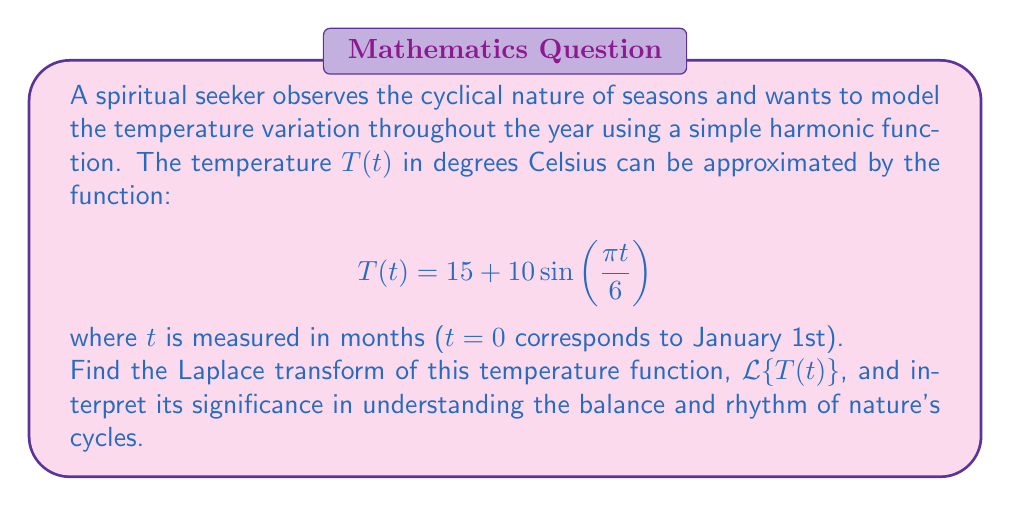Show me your answer to this math problem. To solve this problem, we'll follow these steps:

1) Recall the Laplace transform of a sine function:
   $$\mathcal{L}\{\sin(at)\} = \frac{a}{s^2 + a^2}$$

2) In our case, $a = \frac{\pi}{6}$, so we need to find:
   $$\mathcal{L}\{10\sin(\frac{\pi t}{6})\}$$

3) Using the linearity property of Laplace transforms and the transform of a constant:
   $$\mathcal{L}\{15\} = \frac{15}{s}$$

4) Combining these results:
   $$\mathcal{L}\{T(t)\} = \mathcal{L}\{15 + 10\sin(\frac{\pi t}{6})\}$$
   $$= \mathcal{L}\{15\} + \mathcal{L}\{10\sin(\frac{\pi t}{6})\}$$
   $$= \frac{15}{s} + 10 \cdot \frac{\frac{\pi}{6}}{s^2 + (\frac{\pi}{6})^2}$$

5) Simplifying:
   $$\mathcal{L}\{T(t)\} = \frac{15}{s} + \frac{5\pi}{3s^2 + (\frac{\pi}{6})^2}$$

Interpretation: The Laplace transform provides insights into the balance and rhythm of nature's cycles:

- The term $\frac{15}{s}$ represents the average temperature throughout the year.
- The term $\frac{5\pi}{3s^2 + (\frac{\pi}{6})^2}$ captures the seasonal variations.
- The denominator $3s^2 + (\frac{\pi}{6})^2$ reflects the yearly cycle frequency.

This transform allows us to analyze the temperature function in the frequency domain, highlighting the harmonic nature of seasonal changes and the underlying balance in nature's rhythms.
Answer: $$\mathcal{L}\{T(t)\} = \frac{15}{s} + \frac{5\pi}{3s^2 + (\frac{\pi}{6})^2}$$ 